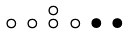<formula> <loc_0><loc_0><loc_500><loc_500>\begin{smallmatrix} & & \circ \\ \circ & \circ & \circ & \circ & \bullet & \bullet & \\ \end{smallmatrix}</formula> 